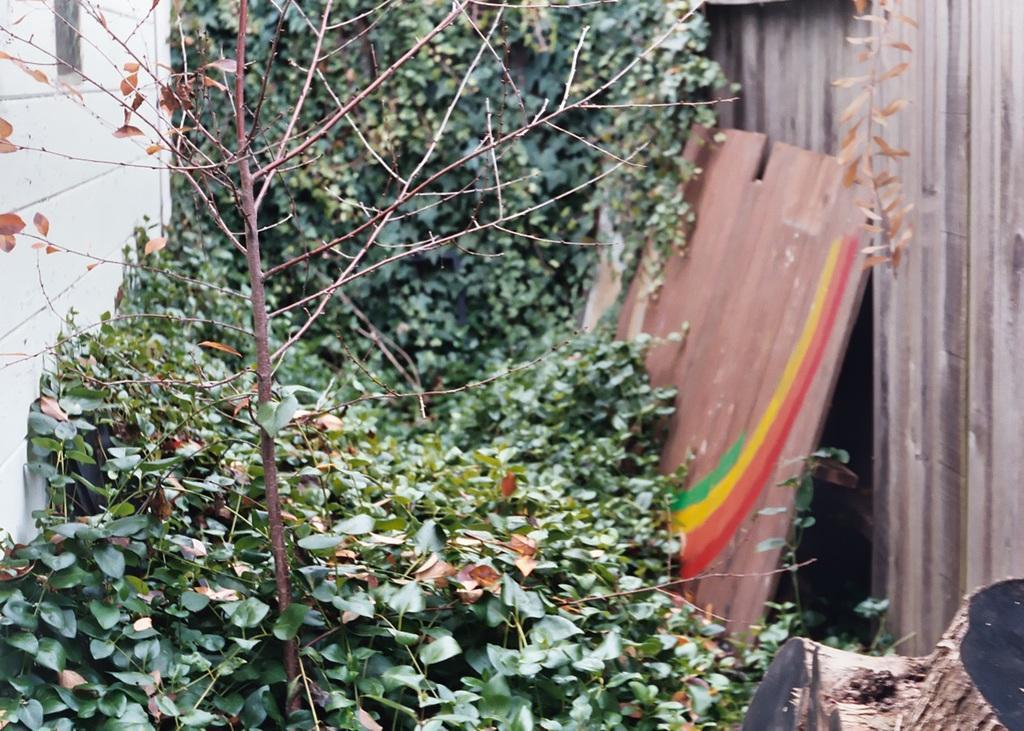Please provide a concise description of this image. In this image I can see the plants. To the left I can see the wall. To the right I can see the wooden objects and the trunk. 